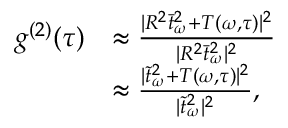<formula> <loc_0><loc_0><loc_500><loc_500>\begin{array} { r l } { g ^ { ( 2 ) } ( \tau ) } & { \approx \frac { | R ^ { 2 } \bar { t } _ { \omega } ^ { 2 } + T ( \omega , \tau ) | ^ { 2 } } { | R ^ { 2 } \bar { t } _ { \omega } ^ { 2 } | ^ { 2 } } } \\ & { \approx \frac { | \tilde { t } _ { \omega } ^ { 2 } + T ( \omega , \tau ) | ^ { 2 } } { | \tilde { t } _ { \omega } ^ { 2 } | ^ { 2 } } , } \end{array}</formula> 